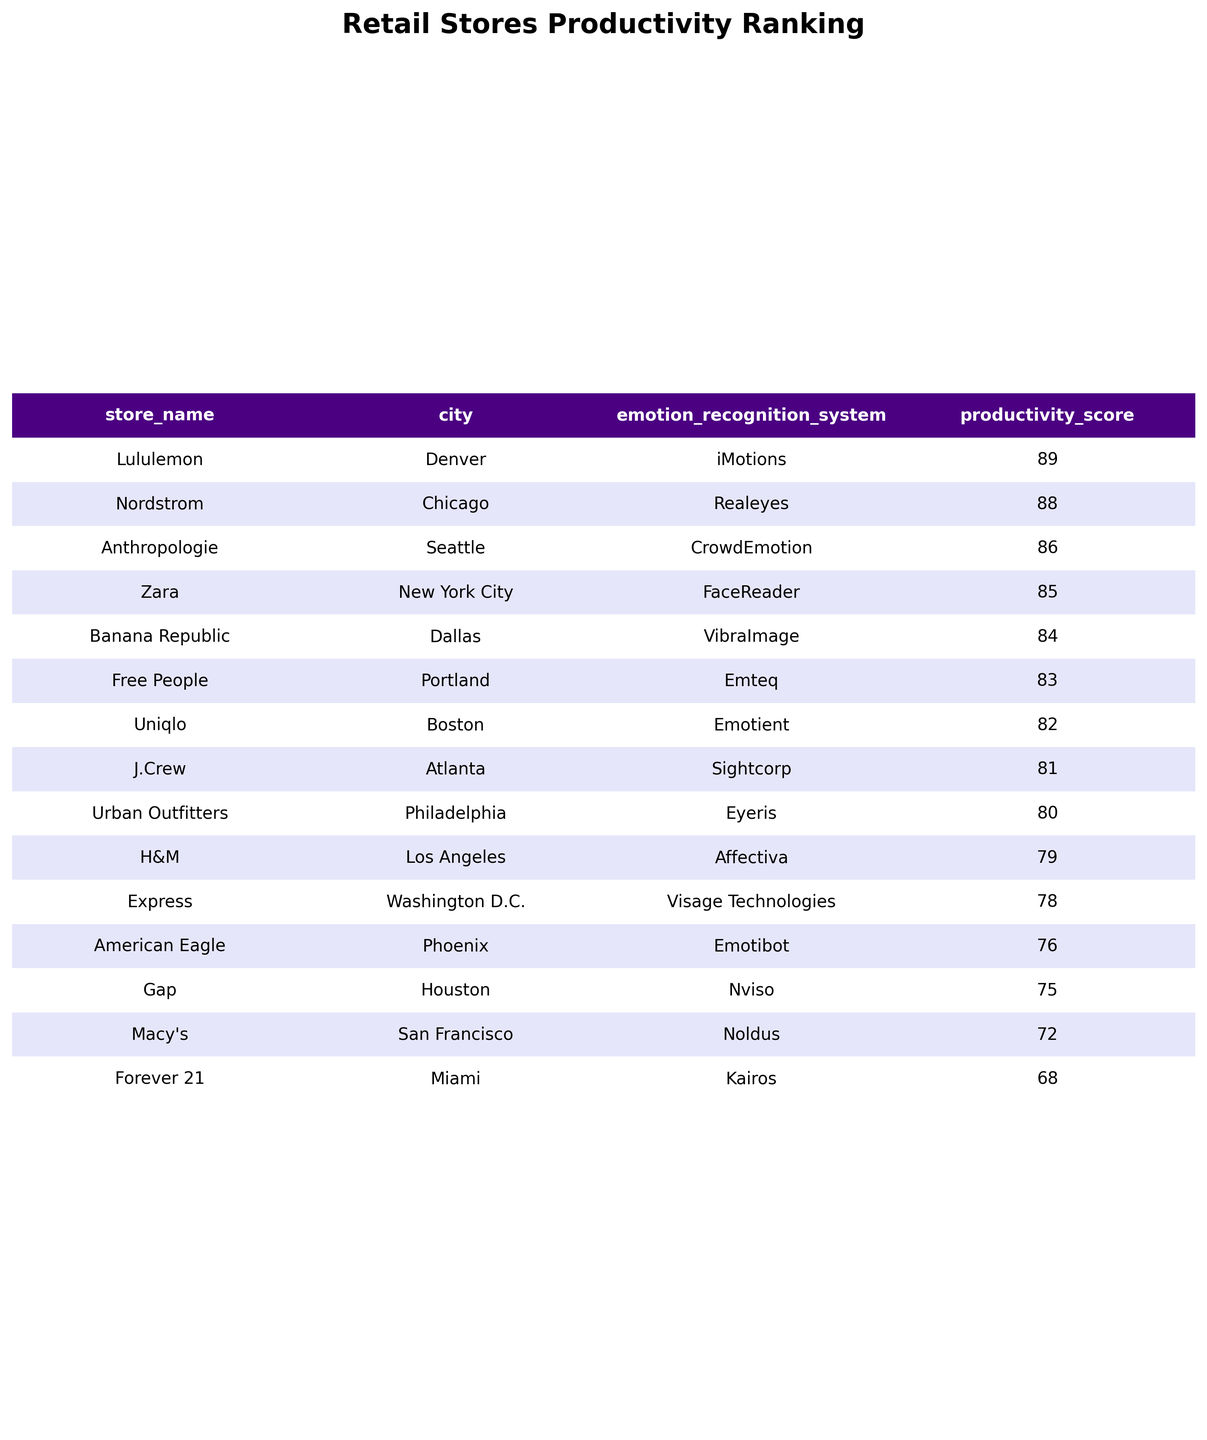What is the productivity score of Nordstrom? Nordstrom's productivity score is listed directly in the table, which shows a score of 88.
Answer: 88 Which store has the lowest average daily sales? The table indicates that Forever 21 has the lowest average daily sales at 6500.
Answer: 6500 What is the average productivity score of stores that use the emotion recognition system "Affectiva"? The only store using Affectiva is H&M, which has a productivity score of 79. Therefore, the average is also 79.
Answer: 79 Is the productivity score higher for stores located in New York City compared to those in Los Angeles? Zara in New York City has a productivity score of 85, while H&M in Los Angeles has a score of 79. Since 85 is greater than 79, the statement is true.
Answer: Yes What is the total average daily sales for all stores using the emotion recognition system "Emotient" and "iMotions"? Emotient is used by Uniqlo with average daily sales of 7900, and iMotions is used by Lululemon with 8700. Adding them gives 7900 + 8700 = 16600.
Answer: 16600 Which city has the store with the highest employee satisfaction score and what is that score? Nordstrom in Chicago has the highest employee satisfaction score of 7.8, as confirmed by comparing all listed scores in the table.
Answer: 7.8 How many stores have a productivity score of 80 or above? By reviewing the table, Zara, Nordstrom, Anthropologie, Lululemon, and Banana Republic are noted for having productivity scores of 85, 88, 86, 89, and 84 respectively, totaling five stores.
Answer: 5 What is the difference in customer conversion rates between stores with productivity scores above 80 and those below? Analyzing the table, stores with scores above 80 (Lululemon, Nordstrom, Zara, Anthropologie, Banana Republic) have an average conversion rate of (0.34 + 0.35 + 0.32 + 0.33 + 0.31) / 5 = 0.33, and those below (H&M, Macy's, Forever 21, Gap) have (0.28 + 0.25 + 0.23 + 0.26) / 4 = 0.26. The difference is 0.33 - 0.26 = 0.07.
Answer: 0.07 What proportion of stores have a customer conversion rate lower than 0.30? The stores with conversion rates below 0.30 are H&M, Macy's, Forever 21, and Gap. There are 4 out of 15 total stores, giving a proportion of 4/15 = 0.267.
Answer: 0.267 Is there a correlation between employee satisfaction score and productivity score across all stores? To evaluate this correlation qualitatively, we notice higher employee satisfaction scores align generally with higher productivity scores, suggesting a potential positive correlation. However, a definitive correlation might require statistical analysis beyond visual inspection.
Answer: Yes (qualitative assessment) What is the average employee satisfaction score for all stores? The employee satisfaction scores (7.2, 6.9, 7.8, 6.5, 7.4, 6.2, 7.6, 7.1, 7.5, 6.8, 7.3, 7.9, 6.7, 7.0, 7.5) sum to 107.2, and dividing by the total number of stores (15) gives us an average of 107.2 / 15 = 7.15.
Answer: 7.15 